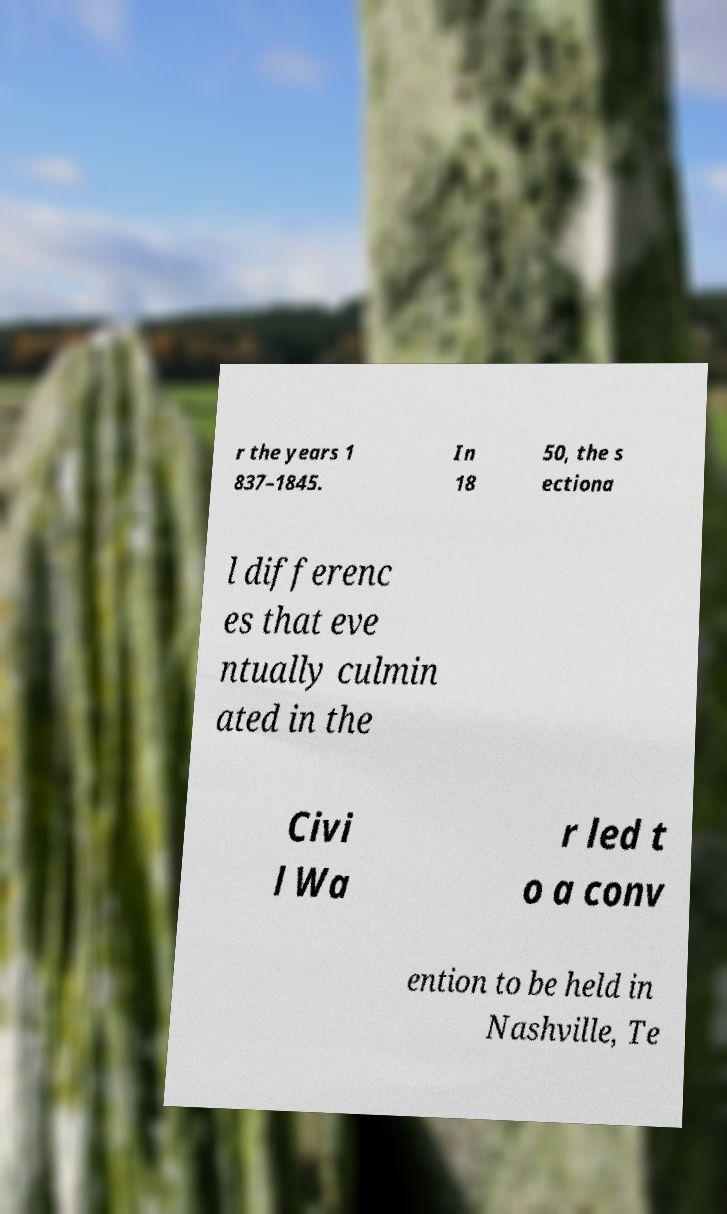Can you read and provide the text displayed in the image?This photo seems to have some interesting text. Can you extract and type it out for me? r the years 1 837–1845. In 18 50, the s ectiona l differenc es that eve ntually culmin ated in the Civi l Wa r led t o a conv ention to be held in Nashville, Te 